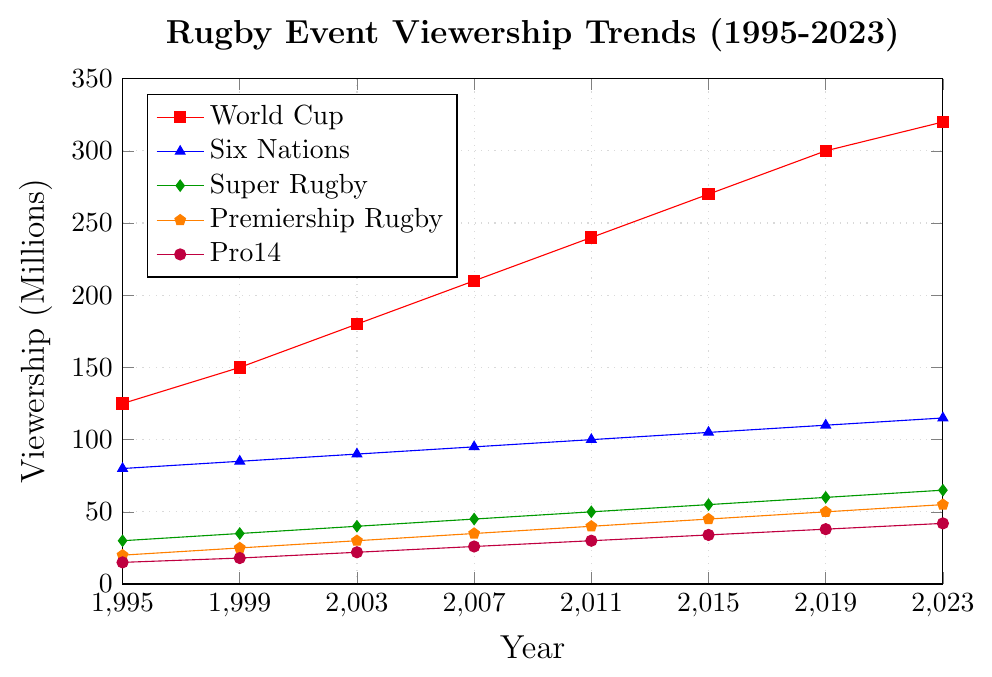Which event has the highest viewership in 2023? The figure shows the viewership trend for various rugby events. In 2023, the event with the highest viewership is the World Cup, depicted by the red line which reaches 320 million.
Answer: World Cup Between which two years did the World Cup viewership increase the most? By analyzing the red line representing the World Cup, the largest increase appears between 2011 (240 million) and 2015 (270 million), an increase of 30 million.
Answer: 2011 to 2015 What is the combined viewership for Six Nations and Super Rugby in 2019? In 2019, the Six Nations has a viewership of 110 million and Super Rugby has 60 million. Combining these values: 110 + 60 = 170 million.
Answer: 170 million Which event showed the most consistent growth in viewership between 1995 and 2023? By observing all the lines, the Premiership Rugby represented by the orange line shows a consistent gradual increase every year without sharp drops or anomalies.
Answer: Premiership Rugby How does the increase in viewership from 1995 to 2023 for Pro14 compare to that of Super Rugby? Pro14 increased from 15 million in 1995 to 42 million in 2023, an increase of 27 million. Super Rugby increased from 30 million in 1995 to 65 million in 2023, an increase of 35 million.
Answer: Pro14: 27 million, Super Rugby: 35 million What was the average annual increase in viewers for the World Cup from 1995 to 2023? The viewership for the World Cup increased from 125 million in 1995 to 320 million in 2023. The total increase is: 320 - 125 = 195 million over 28 years. The average annual increase is: 195 / 28 ≈ 6.96 million per year.
Answer: 6.96 million per year In which year did Premiership Rugby surpass 30 million viewers? Reviewing the orange line for Premiership Rugby, it surpasses 30 million viewers in 2007 where it reaches 35 million.
Answer: 2007 What is the difference in viewership between Six Nations and Pro14 in the year 2003? In 2003, Six Nations had 90 million viewers and Pro14 had 22 million viewers. The difference is: 90 - 22 = 68 million.
Answer: 68 million Which two events had the closest viewership figures in 2015? In 2015, the viewership figures are closely analyzed for each event. Premiership Rugby had 45 million and Pro14 had 34 million, with a difference of 11 million which is closer compared to the differences among other events.
Answer: Premiership Rugby and Pro14 